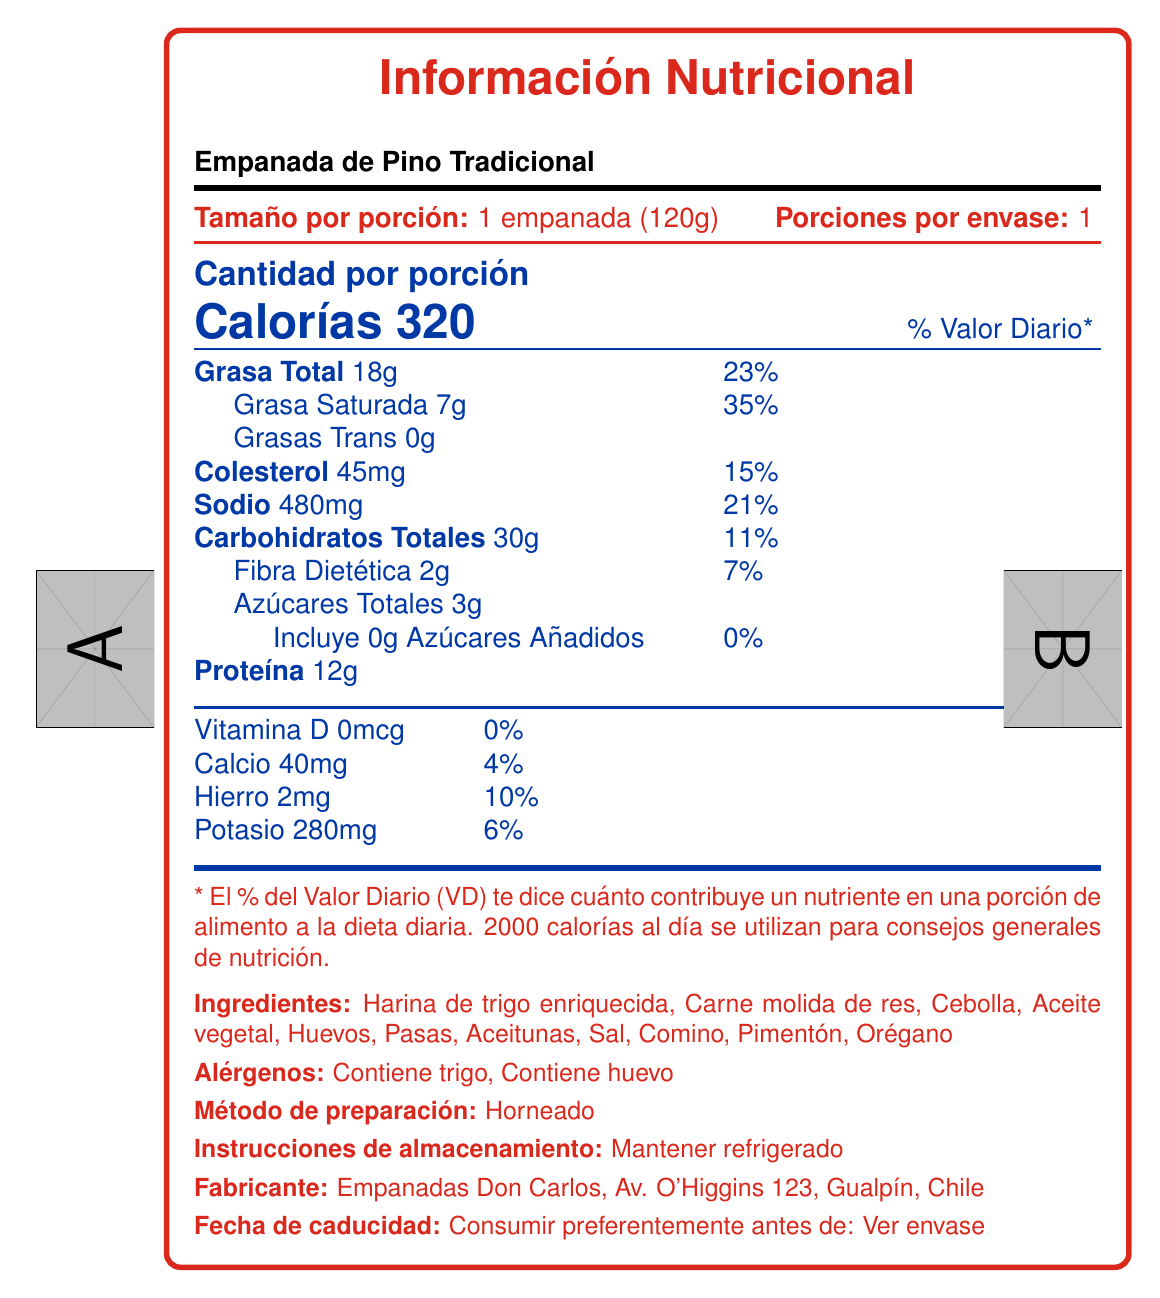What is the serving size of the empanada? The serving size is clearly stated as "1 empanada (120g)" in the document.
Answer: 1 empanada (120g) How many calories does one serving of Empanada de Pino Tradicional contain? The document specifies that one serving contains 320 calories.
Answer: 320 calories How much saturated fat is in one serving? Under the "Grasa Total" section, it lists "Grasa Saturada" as 7g.
Answer: 7g What percentage of the daily value of sodium does one empanada provide? The sodium content is listed as 480mg, which is 21% of the daily value.
Answer: 21% What ingredients are used in this empanada? The ingredients are listed at the bottom of the document under "Ingredientes".
Answer: Harina de trigo enriquecida, Carne molida de res, Cebolla, Aceite vegetal, Huevos, Pasas, Aceitunas, Sal, Comino, Pimentón, Orégano What is the method of preparation for this empanada? The preparation method is explicitly mentioned as "Horneado".
Answer: Horneado How much cholesterol is in one serving of the empanada? The cholesterol content is listed as 45mg.
Answer: 45mg Which of these is NOT an allergen found in the empanada?
A. Trigo
B. Huevo
C. Leche The document lists the allergens as "Contiene trigo" and "Contiene huevo".
Answer: C. Leche What is the daily value percentage of dietary fiber in one serving? A. 7% B. 10% C. 15% D. 21% The dietary fiber value is listed as 2g, which is 7% of the daily value.
Answer: A. 7% Does the document provide storage instructions? The storage instructions are mentioned as "Mantener refrigerado".
Answer: Yes Describe the main idea of the document. The document covers comprehensive nutritional details about the empanada, addressing several aspects from nutritional values to manufacturer details and storage instructions.
Answer: The document provides detailed nutritional information for Empanada de Pino Tradicional, including serving size, calories, fats, cholesterol, sodium, carbohydrate, protein, vitamins and minerals, ingredients, allergens, preparation method, storage instructions, manufacturer information, and expiration date. Who is the manufacturer of the empanada? The document lists "Empanadas Don Carlos" as the manufacturer.
Answer: Empanadas Don Carlos What is the expiration date of the empanada? The expiration date is indicated as "Consumir preferentemente antes de: Ver envase".
Answer: Consumir preferentemente antes de: Ver envase Is there any trans fat in the empanada? The document lists "Grasas Trans" as 0g.
Answer: No How should the empanada be stored? The document specifies to keep the empanada refrigerated.
Answer: Mantener refrigerado How much iron does one serving of the empanada provide? The iron content is listed as 2mg.
Answer: 2mg Does the empanada contain any added sugars? The document shows "Incluye 0g Azúcares Añadidos".
Answer: No What address is given for the manufacturer? The manufacturer's address is listed as "Av. O'Higgins 123, Gualpín, Chile".
Answer: Av. O'Higgins 123, Gualpín, Chile What is the total carbohydrate content per serving? The total carbohydrate content per serving is listed as 30g.
Answer: 30g What is the brand's logo and design on the packaging like? The document does not provide any visual details or descriptions about the brand's logo or design on the packaging.
Answer: Cannot be determined 